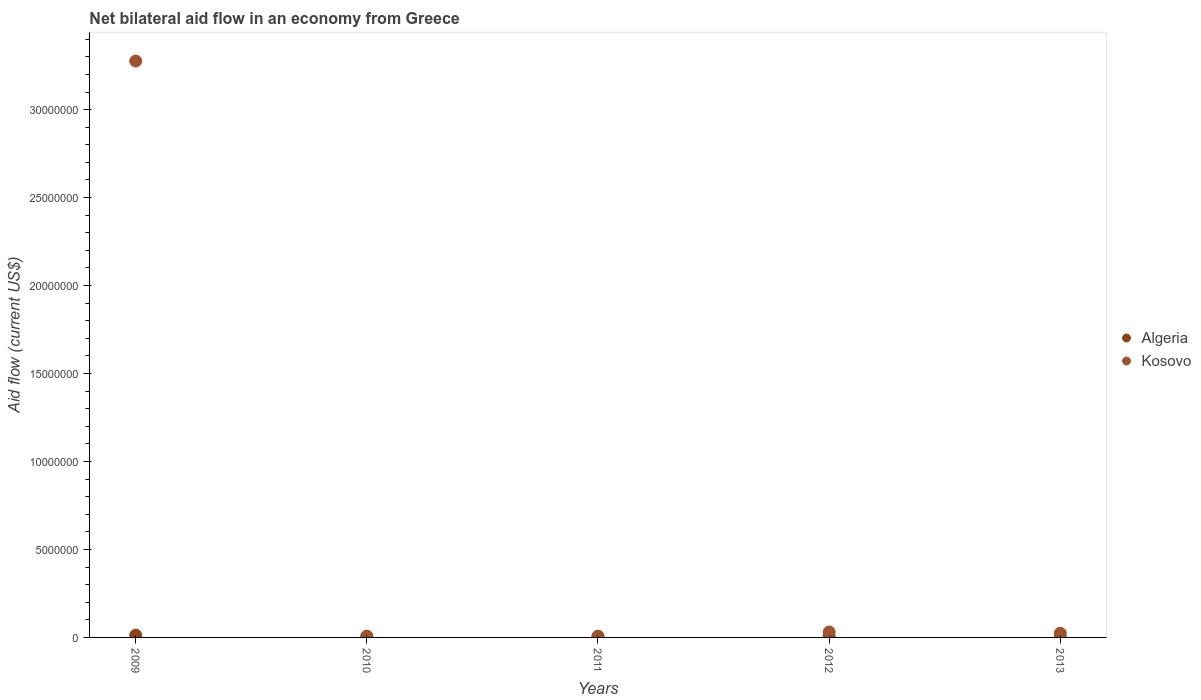Across all years, what is the minimum net bilateral aid flow in Algeria?
Your response must be concise. 2.00e+04. In which year was the net bilateral aid flow in Kosovo maximum?
Your answer should be very brief. 2009. In which year was the net bilateral aid flow in Algeria minimum?
Your answer should be compact. 2013. What is the difference between the net bilateral aid flow in Kosovo in 2009 and the net bilateral aid flow in Algeria in 2012?
Offer a very short reply. 3.27e+07. What is the average net bilateral aid flow in Algeria per year?
Your answer should be very brief. 7.00e+04. In how many years, is the net bilateral aid flow in Kosovo greater than 26000000 US$?
Ensure brevity in your answer.  1. What is the ratio of the net bilateral aid flow in Kosovo in 2009 to that in 2013?
Ensure brevity in your answer.  136.5. Is the net bilateral aid flow in Algeria in 2009 less than that in 2011?
Your answer should be compact. No. What is the difference between the highest and the second highest net bilateral aid flow in Kosovo?
Provide a short and direct response. 3.24e+07. In how many years, is the net bilateral aid flow in Algeria greater than the average net bilateral aid flow in Algeria taken over all years?
Provide a short and direct response. 1. Is the net bilateral aid flow in Algeria strictly greater than the net bilateral aid flow in Kosovo over the years?
Make the answer very short. No. Is the net bilateral aid flow in Algeria strictly less than the net bilateral aid flow in Kosovo over the years?
Provide a succinct answer. No. How many dotlines are there?
Your answer should be compact. 2. What is the difference between two consecutive major ticks on the Y-axis?
Offer a very short reply. 5.00e+06. Are the values on the major ticks of Y-axis written in scientific E-notation?
Make the answer very short. No. Does the graph contain grids?
Your response must be concise. No. Where does the legend appear in the graph?
Make the answer very short. Center right. How many legend labels are there?
Your answer should be very brief. 2. How are the legend labels stacked?
Your answer should be very brief. Vertical. What is the title of the graph?
Give a very brief answer. Net bilateral aid flow in an economy from Greece. Does "Russian Federation" appear as one of the legend labels in the graph?
Offer a very short reply. No. What is the Aid flow (current US$) of Kosovo in 2009?
Keep it short and to the point. 3.28e+07. What is the Aid flow (current US$) of Algeria in 2010?
Provide a succinct answer. 7.00e+04. What is the Aid flow (current US$) in Kosovo in 2010?
Offer a very short reply. 3.00e+04. What is the Aid flow (current US$) of Algeria in 2011?
Provide a short and direct response. 7.00e+04. What is the Aid flow (current US$) in Algeria in 2012?
Offer a terse response. 6.00e+04. What is the Aid flow (current US$) in Kosovo in 2012?
Make the answer very short. 3.10e+05. What is the Aid flow (current US$) of Algeria in 2013?
Offer a very short reply. 2.00e+04. What is the Aid flow (current US$) of Kosovo in 2013?
Your answer should be very brief. 2.40e+05. Across all years, what is the maximum Aid flow (current US$) in Algeria?
Provide a short and direct response. 1.30e+05. Across all years, what is the maximum Aid flow (current US$) in Kosovo?
Provide a succinct answer. 3.28e+07. What is the total Aid flow (current US$) in Algeria in the graph?
Give a very brief answer. 3.50e+05. What is the total Aid flow (current US$) in Kosovo in the graph?
Offer a terse response. 3.34e+07. What is the difference between the Aid flow (current US$) of Algeria in 2009 and that in 2010?
Keep it short and to the point. 6.00e+04. What is the difference between the Aid flow (current US$) of Kosovo in 2009 and that in 2010?
Give a very brief answer. 3.27e+07. What is the difference between the Aid flow (current US$) in Kosovo in 2009 and that in 2011?
Your response must be concise. 3.27e+07. What is the difference between the Aid flow (current US$) in Kosovo in 2009 and that in 2012?
Your answer should be compact. 3.24e+07. What is the difference between the Aid flow (current US$) in Kosovo in 2009 and that in 2013?
Keep it short and to the point. 3.25e+07. What is the difference between the Aid flow (current US$) of Algeria in 2010 and that in 2011?
Your answer should be very brief. 0. What is the difference between the Aid flow (current US$) of Kosovo in 2010 and that in 2011?
Give a very brief answer. 0. What is the difference between the Aid flow (current US$) of Kosovo in 2010 and that in 2012?
Provide a short and direct response. -2.80e+05. What is the difference between the Aid flow (current US$) in Algeria in 2010 and that in 2013?
Your answer should be very brief. 5.00e+04. What is the difference between the Aid flow (current US$) of Kosovo in 2010 and that in 2013?
Provide a short and direct response. -2.10e+05. What is the difference between the Aid flow (current US$) of Algeria in 2011 and that in 2012?
Offer a terse response. 10000. What is the difference between the Aid flow (current US$) of Kosovo in 2011 and that in 2012?
Your answer should be compact. -2.80e+05. What is the difference between the Aid flow (current US$) of Algeria in 2011 and that in 2013?
Provide a succinct answer. 5.00e+04. What is the difference between the Aid flow (current US$) in Algeria in 2009 and the Aid flow (current US$) in Kosovo in 2011?
Ensure brevity in your answer.  1.00e+05. What is the difference between the Aid flow (current US$) of Algeria in 2009 and the Aid flow (current US$) of Kosovo in 2012?
Offer a terse response. -1.80e+05. What is the difference between the Aid flow (current US$) of Algeria in 2010 and the Aid flow (current US$) of Kosovo in 2012?
Give a very brief answer. -2.40e+05. What is the average Aid flow (current US$) in Kosovo per year?
Your response must be concise. 6.67e+06. In the year 2009, what is the difference between the Aid flow (current US$) in Algeria and Aid flow (current US$) in Kosovo?
Offer a terse response. -3.26e+07. In the year 2010, what is the difference between the Aid flow (current US$) in Algeria and Aid flow (current US$) in Kosovo?
Your answer should be very brief. 4.00e+04. In the year 2011, what is the difference between the Aid flow (current US$) of Algeria and Aid flow (current US$) of Kosovo?
Your answer should be compact. 4.00e+04. In the year 2013, what is the difference between the Aid flow (current US$) of Algeria and Aid flow (current US$) of Kosovo?
Make the answer very short. -2.20e+05. What is the ratio of the Aid flow (current US$) of Algeria in 2009 to that in 2010?
Keep it short and to the point. 1.86. What is the ratio of the Aid flow (current US$) in Kosovo in 2009 to that in 2010?
Keep it short and to the point. 1092. What is the ratio of the Aid flow (current US$) in Algeria in 2009 to that in 2011?
Provide a succinct answer. 1.86. What is the ratio of the Aid flow (current US$) in Kosovo in 2009 to that in 2011?
Offer a terse response. 1092. What is the ratio of the Aid flow (current US$) of Algeria in 2009 to that in 2012?
Provide a succinct answer. 2.17. What is the ratio of the Aid flow (current US$) of Kosovo in 2009 to that in 2012?
Provide a short and direct response. 105.68. What is the ratio of the Aid flow (current US$) in Kosovo in 2009 to that in 2013?
Offer a very short reply. 136.5. What is the ratio of the Aid flow (current US$) of Kosovo in 2010 to that in 2011?
Provide a succinct answer. 1. What is the ratio of the Aid flow (current US$) of Algeria in 2010 to that in 2012?
Provide a short and direct response. 1.17. What is the ratio of the Aid flow (current US$) of Kosovo in 2010 to that in 2012?
Your response must be concise. 0.1. What is the ratio of the Aid flow (current US$) in Kosovo in 2011 to that in 2012?
Your answer should be compact. 0.1. What is the ratio of the Aid flow (current US$) of Algeria in 2011 to that in 2013?
Your answer should be very brief. 3.5. What is the ratio of the Aid flow (current US$) in Kosovo in 2011 to that in 2013?
Give a very brief answer. 0.12. What is the ratio of the Aid flow (current US$) of Kosovo in 2012 to that in 2013?
Your answer should be compact. 1.29. What is the difference between the highest and the second highest Aid flow (current US$) in Kosovo?
Your answer should be compact. 3.24e+07. What is the difference between the highest and the lowest Aid flow (current US$) in Kosovo?
Ensure brevity in your answer.  3.27e+07. 